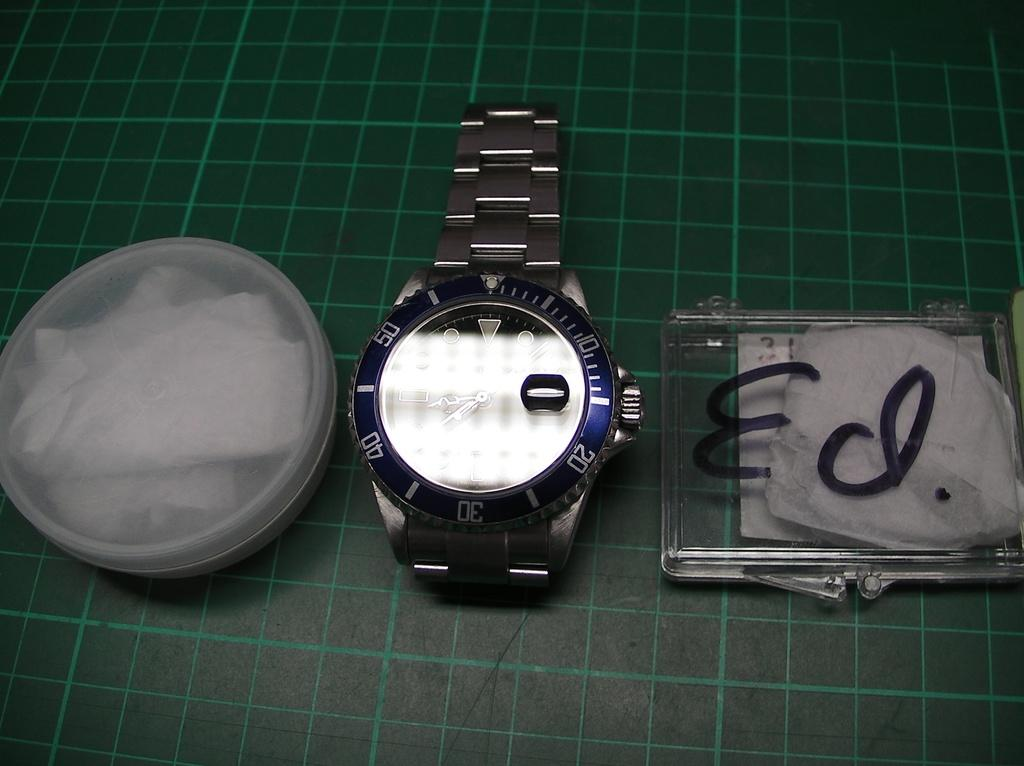<image>
Share a concise interpretation of the image provided. A silver and blue watch sits between two containers, one of which has Ed. written on it in black marker. 